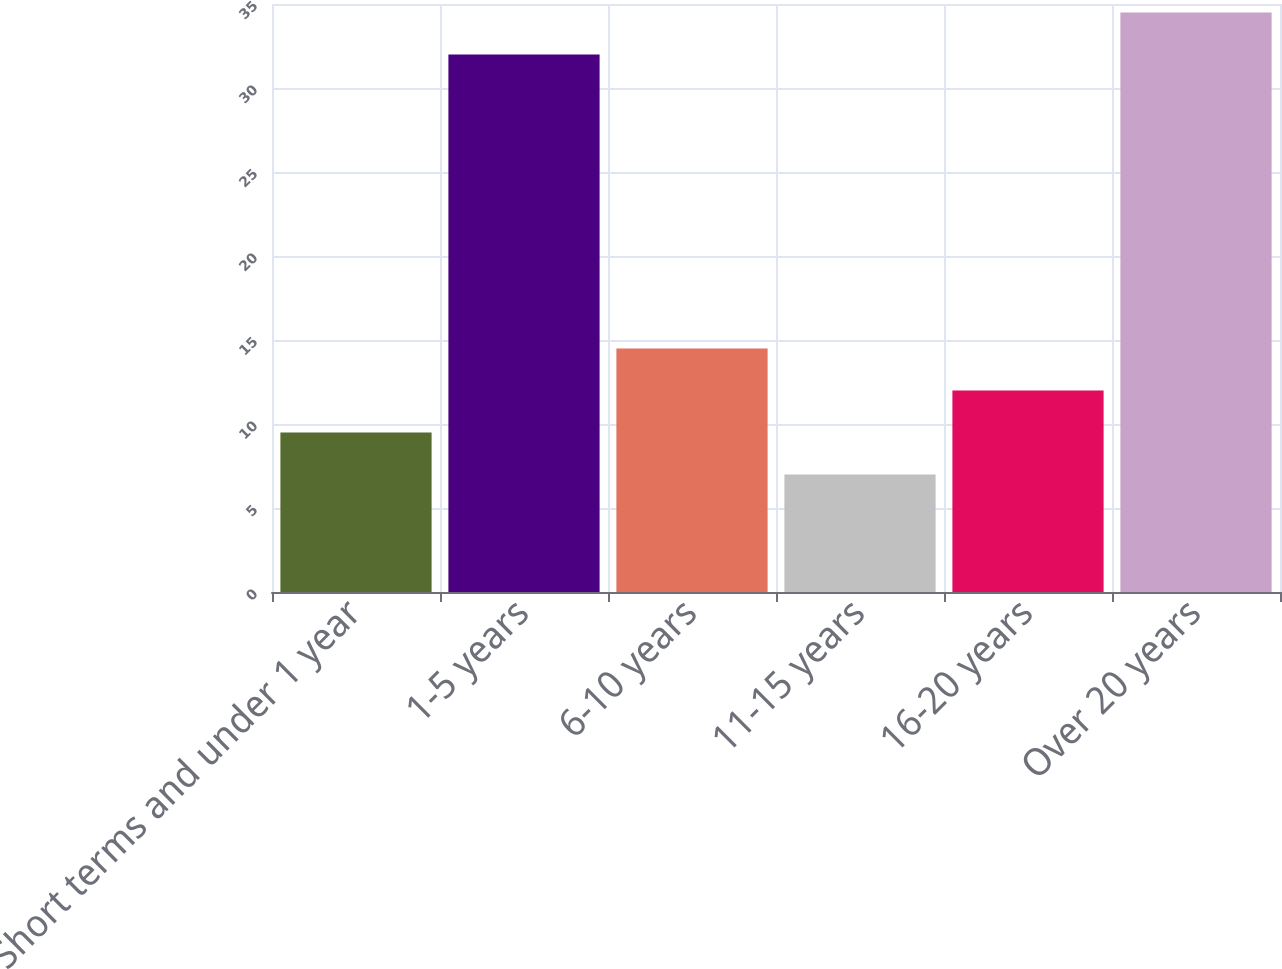Convert chart to OTSL. <chart><loc_0><loc_0><loc_500><loc_500><bar_chart><fcel>Short terms and under 1 year<fcel>1-5 years<fcel>6-10 years<fcel>11-15 years<fcel>16-20 years<fcel>Over 20 years<nl><fcel>9.5<fcel>32<fcel>14.5<fcel>7<fcel>12<fcel>34.5<nl></chart> 